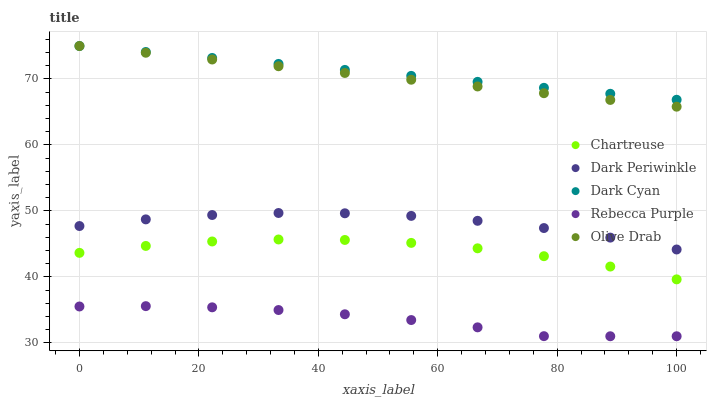Does Rebecca Purple have the minimum area under the curve?
Answer yes or no. Yes. Does Dark Cyan have the maximum area under the curve?
Answer yes or no. Yes. Does Chartreuse have the minimum area under the curve?
Answer yes or no. No. Does Chartreuse have the maximum area under the curve?
Answer yes or no. No. Is Olive Drab the smoothest?
Answer yes or no. Yes. Is Chartreuse the roughest?
Answer yes or no. Yes. Is Dark Periwinkle the smoothest?
Answer yes or no. No. Is Dark Periwinkle the roughest?
Answer yes or no. No. Does Rebecca Purple have the lowest value?
Answer yes or no. Yes. Does Chartreuse have the lowest value?
Answer yes or no. No. Does Olive Drab have the highest value?
Answer yes or no. Yes. Does Chartreuse have the highest value?
Answer yes or no. No. Is Chartreuse less than Dark Periwinkle?
Answer yes or no. Yes. Is Dark Cyan greater than Rebecca Purple?
Answer yes or no. Yes. Does Dark Cyan intersect Olive Drab?
Answer yes or no. Yes. Is Dark Cyan less than Olive Drab?
Answer yes or no. No. Is Dark Cyan greater than Olive Drab?
Answer yes or no. No. Does Chartreuse intersect Dark Periwinkle?
Answer yes or no. No. 